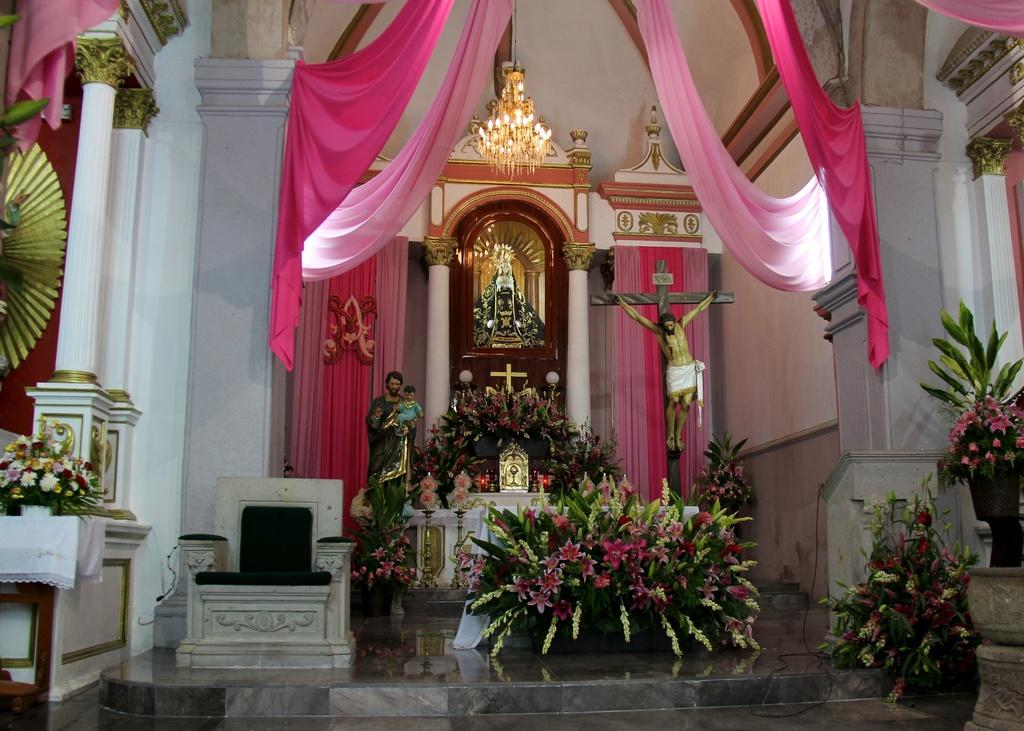What type of building is shown in the image? The image is an inside view of a church. What decorative elements can be seen in the image? There are sculptures, plants, and flowers in the image. What type of window treatment is present in the image? There are curtains in the image. What type of lighting is present in the image? There are lights in the image. What type of seating is present in the image? There are chairs in the image. What type of architectural feature is present in the image? There is a wall in the image. What type of garden can be seen through the window in the image? There is no window visible in the image, so it is not possible to see a garden through it. 